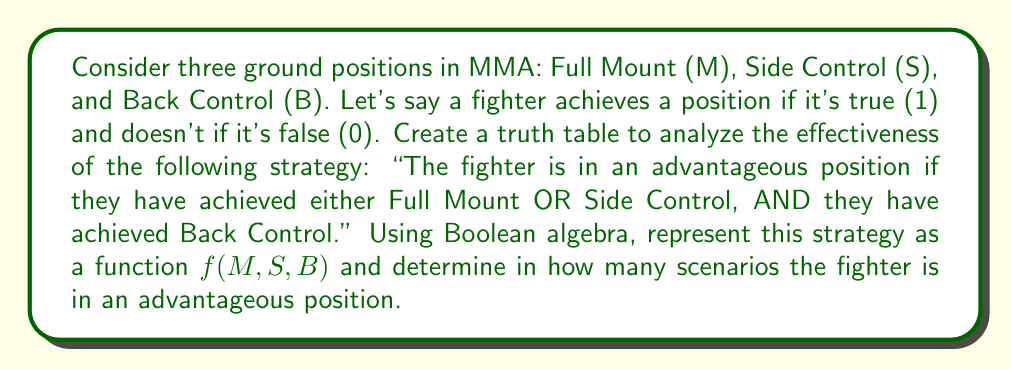Can you answer this question? Let's approach this step-by-step:

1) First, we need to translate the strategy into a Boolean expression:
   $f(M,S,B) = (M \lor S) \land B$

2) Now, let's create a truth table for this function:

   | M | S | B | M ∨ S | (M ∨ S) ∧ B | f(M,S,B) |
   |---|---|---|-------|--------------|----------|
   | 0 | 0 | 0 |   0   |      0       |    0     |
   | 0 | 0 | 1 |   0   |      0       |    0     |
   | 0 | 1 | 0 |   1   |      0       |    0     |
   | 0 | 1 | 1 |   1   |      1       |    1     |
   | 1 | 0 | 0 |   1   |      0       |    0     |
   | 1 | 0 | 1 |   1   |      1       |    1     |
   | 1 | 1 | 0 |   1   |      0       |    0     |
   | 1 | 1 | 1 |   1   |      1       |    1     |

3) Analyzing the truth table:
   - The function $f(M,S,B)$ is true (1) in 3 scenarios:
     a) When S = 1, B = 1 (regardless of M)
     b) When M = 1, B = 1 (regardless of S)

4) Therefore, the fighter is in an advantageous position in 3 out of the 8 possible scenarios.

This analysis shows that achieving Back Control is crucial for this strategy, as it's a necessary condition for being in an advantageous position. Either Full Mount or Side Control must also be achieved for the strategy to be successful.
Answer: 3 scenarios 